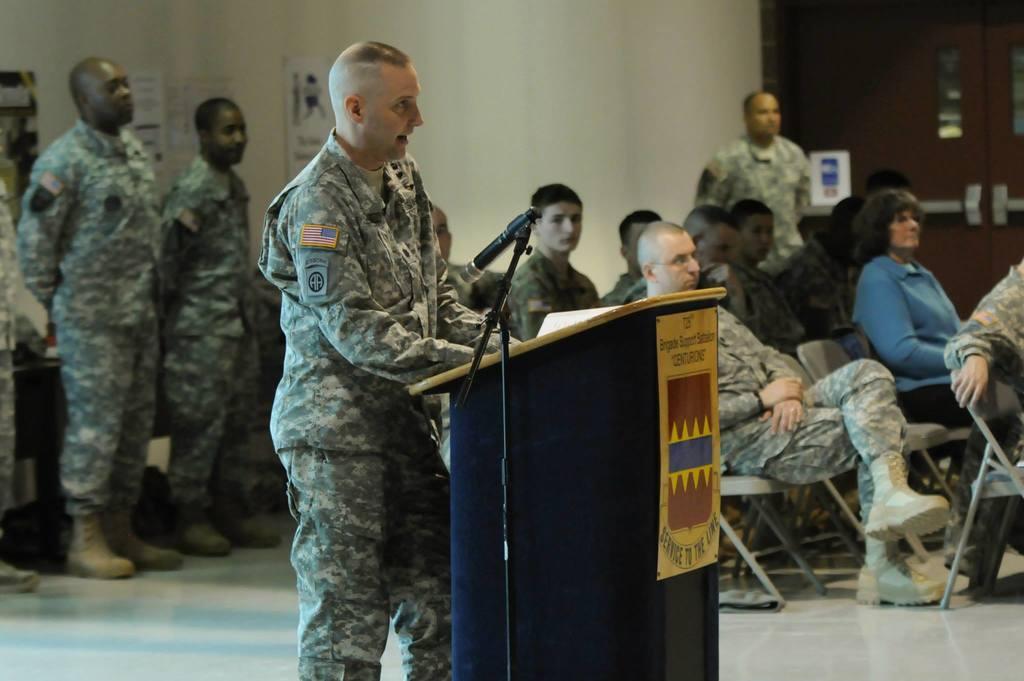Please provide a concise description of this image. Here we can see few persons. He is talking on the mike and this is a podium. There are few persons sitting on the chairs. This is floor. In the background we can see a door, posters, and wall. 